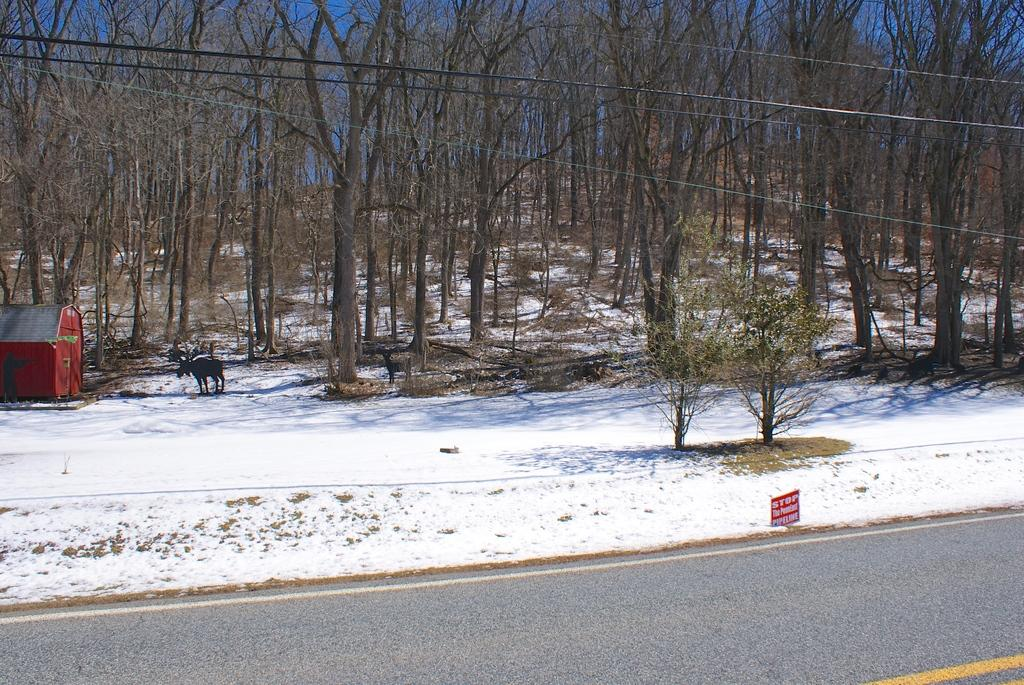What is located in the center of the image? There are trees in the center of the image. What can be seen at the bottom of the image? There is a road visible at the bottom of the image. What is the weather condition in the image? Snow is present in the image, indicating a cold or wintery condition. What is on the left side of the image? There is an animal and a shed on the left side of the image. What is present at the top of the image? Wires are visible at the top of the image. How far away is the haircut salon from the shed in the image? There is no haircut salon present in the image, so it is not possible to determine the distance between it and the shed. 